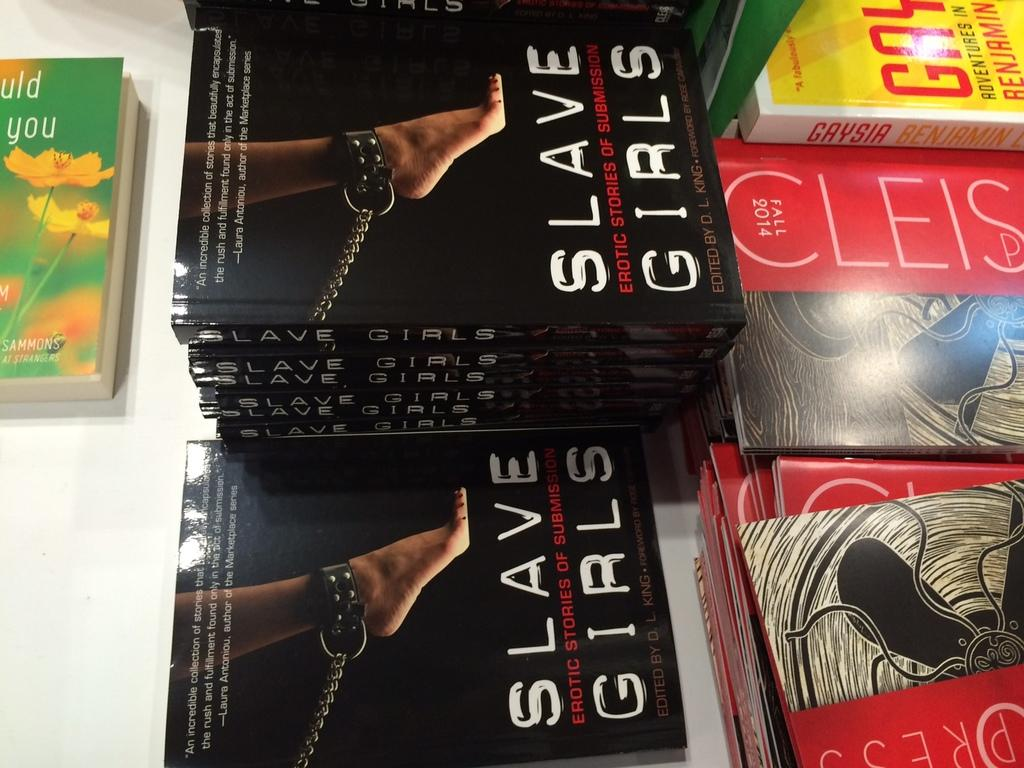Provide a one-sentence caption for the provided image. A stack of books titled "Slave Girls." sitting on a white table. 